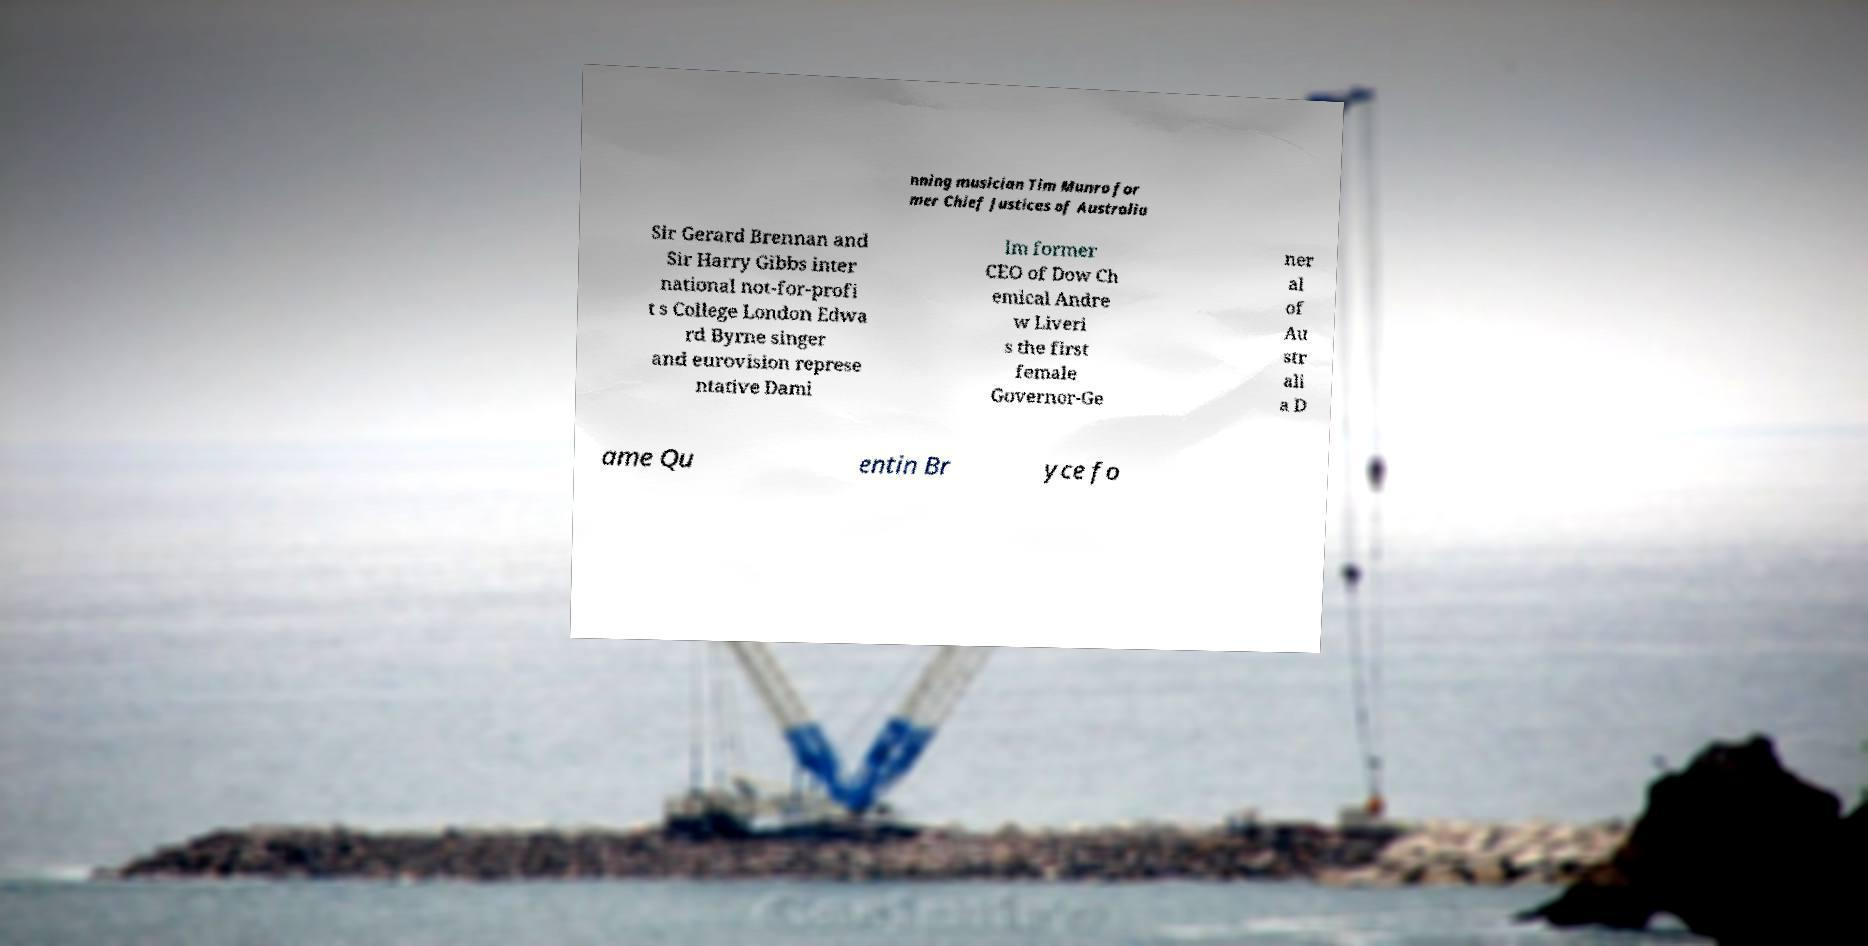Please identify and transcribe the text found in this image. nning musician Tim Munro for mer Chief Justices of Australia Sir Gerard Brennan and Sir Harry Gibbs inter national not-for-profi t s College London Edwa rd Byrne singer and eurovision represe ntative Dami Im former CEO of Dow Ch emical Andre w Liveri s the first female Governor-Ge ner al of Au str ali a D ame Qu entin Br yce fo 